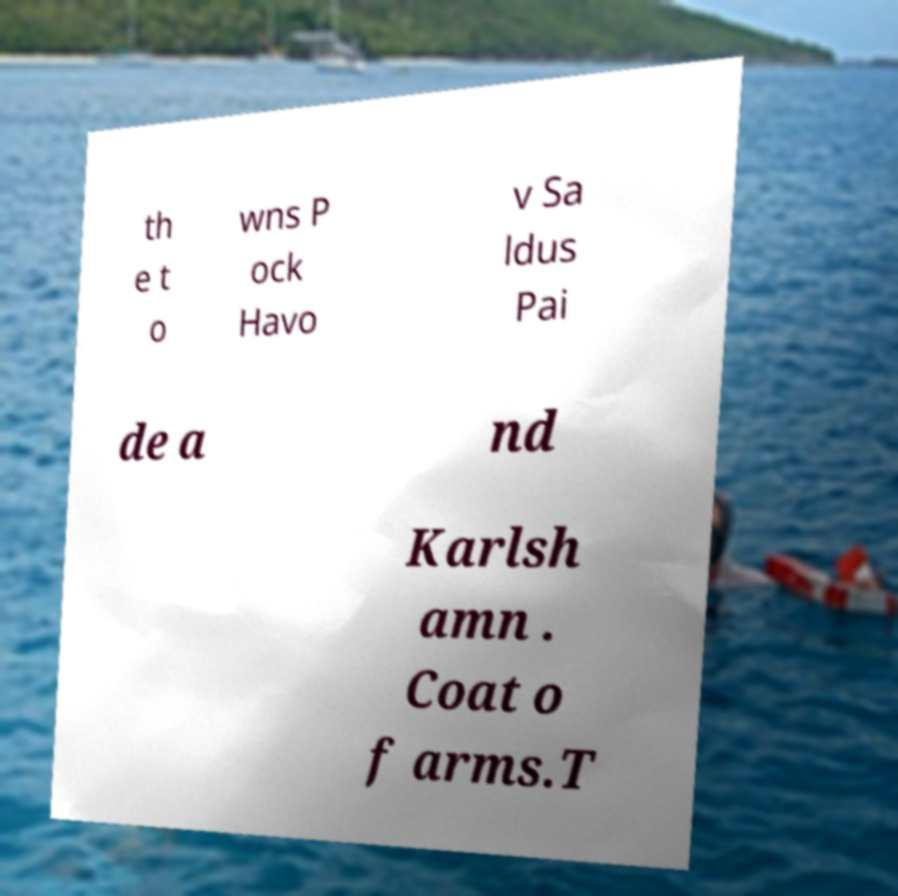Please identify and transcribe the text found in this image. th e t o wns P ock Havo v Sa ldus Pai de a nd Karlsh amn . Coat o f arms.T 